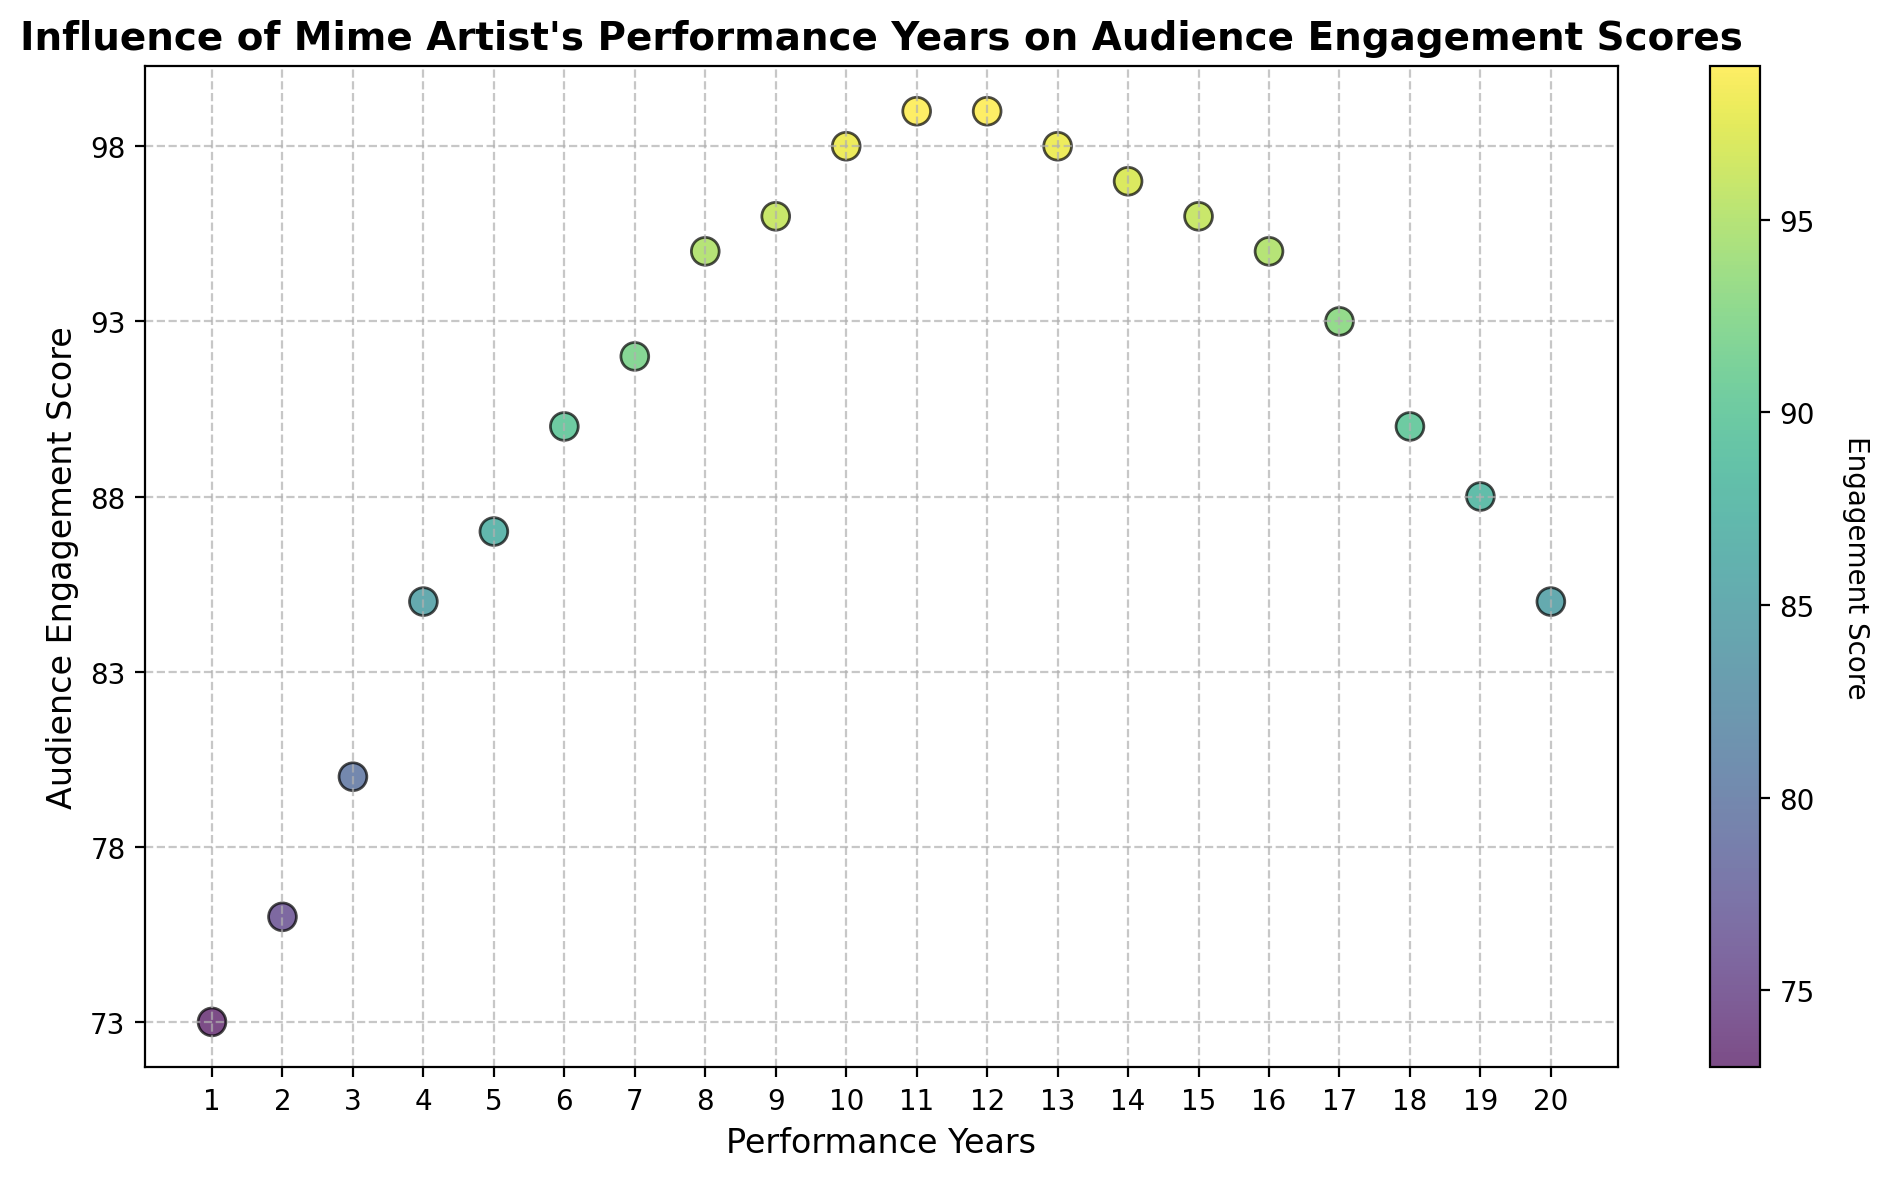What's the trend in Audience Engagement Scores as Performance Years increase? As you move from left (Performance Year 1) to right (Performance Year 20) on the x-axis, the Audience Engagement Scores rise initially, peaking around Year 12, then gradually decline.
Answer: Initial rise, peak at Year 12, gradual decline In which Performance Year does the Audience Engagement Score reach its maximum value? Look for the highest point on the y-axis. The maximum Audience Engagement Score is 99, which occurs in Performance Years 11 and 12.
Answer: Year 11, Year 12 How does the color change from Performance Year 1 to Performance Year 20? The scatter plot uses a color gradient (viridis colormap) where colors become brighter as the Audience Engagement Score increases and dimmer as it decreases.
Answer: Brighter, then dimmer Which Performance Year(s) have the lowest Audience Engagement Scores? Identify the lowest points on the y-axis. The minimum Audience Engagement Score is 73, which occurs in Performance Year 1.
Answer: Year 1 Compare the Audience Engagement Scores between Performance Years 5 and 15. Which year has a higher score? Look at the points corresponding to Performance Years 5 and 15. Performance Year 5 has a score of 87, and Performance Year 15 has a score of 96.
Answer: Year 15 What is the average Audience Engagement Score for the first 5 Performance Years? Add the scores for the first 5 Performance Years (73 + 76 + 80 + 85 + 87) and divide by 5. (73 + 76 + 80 + 85 + 87) / 5 = 80.2
Answer: 80.2 Describe the pattern in Audience Engagement Scores after the peak year. After the peak in Performance Year 12 (scores 99), there's a gradual decline until Year 20 (score 85).
Answer: Gradual decline What is the difference in Audience Engagement Scores between the peak year and the final year? The peak Audience Engagement Score is 99 (Year 12), and the final year's score is 85. The difference is 99 - 85 = 14.
Answer: 14 How many Performance Years have an Audience Engagement Score of 95 or above? Count the number of data points with a score of 95 or higher. They are Years 8, 9, 10, 11, and 12 (5 years total).
Answer: 5 years Is there any Performance Year where the Audience Engagement Score remains constant compared to the previous year? Look for consecutive points with the same y-value. The Audience Engagement Score remains 99 in both Year 11 and Year 12.
Answer: Year 11 to Year 12 